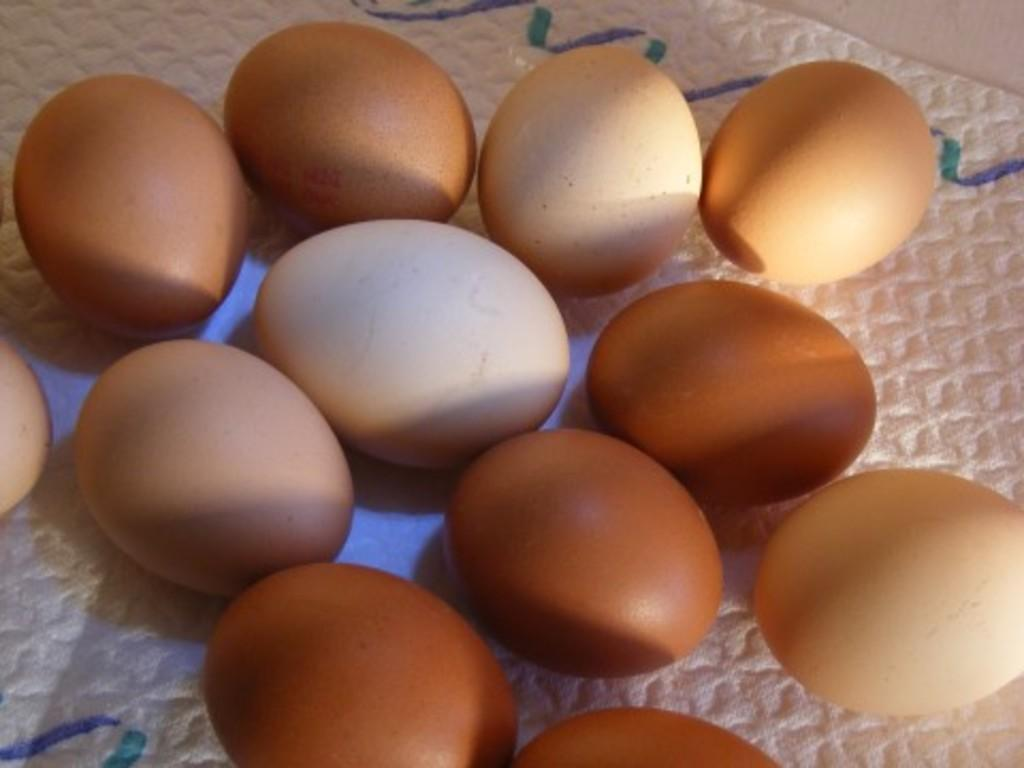What type of food item is present in the image? There are eggs in the image. Can you describe the appearance of the eggs? The eggs are brown and cream in color in the image. What is the color of the surface on which the eggs are placed? The eggs are on a white colored surface. What type of cherry is placed on top of the gold-plated eggs in the image? There is no cherry or gold-plated eggs present in the image; it only features brown and cream-colored eggs on a white surface. 